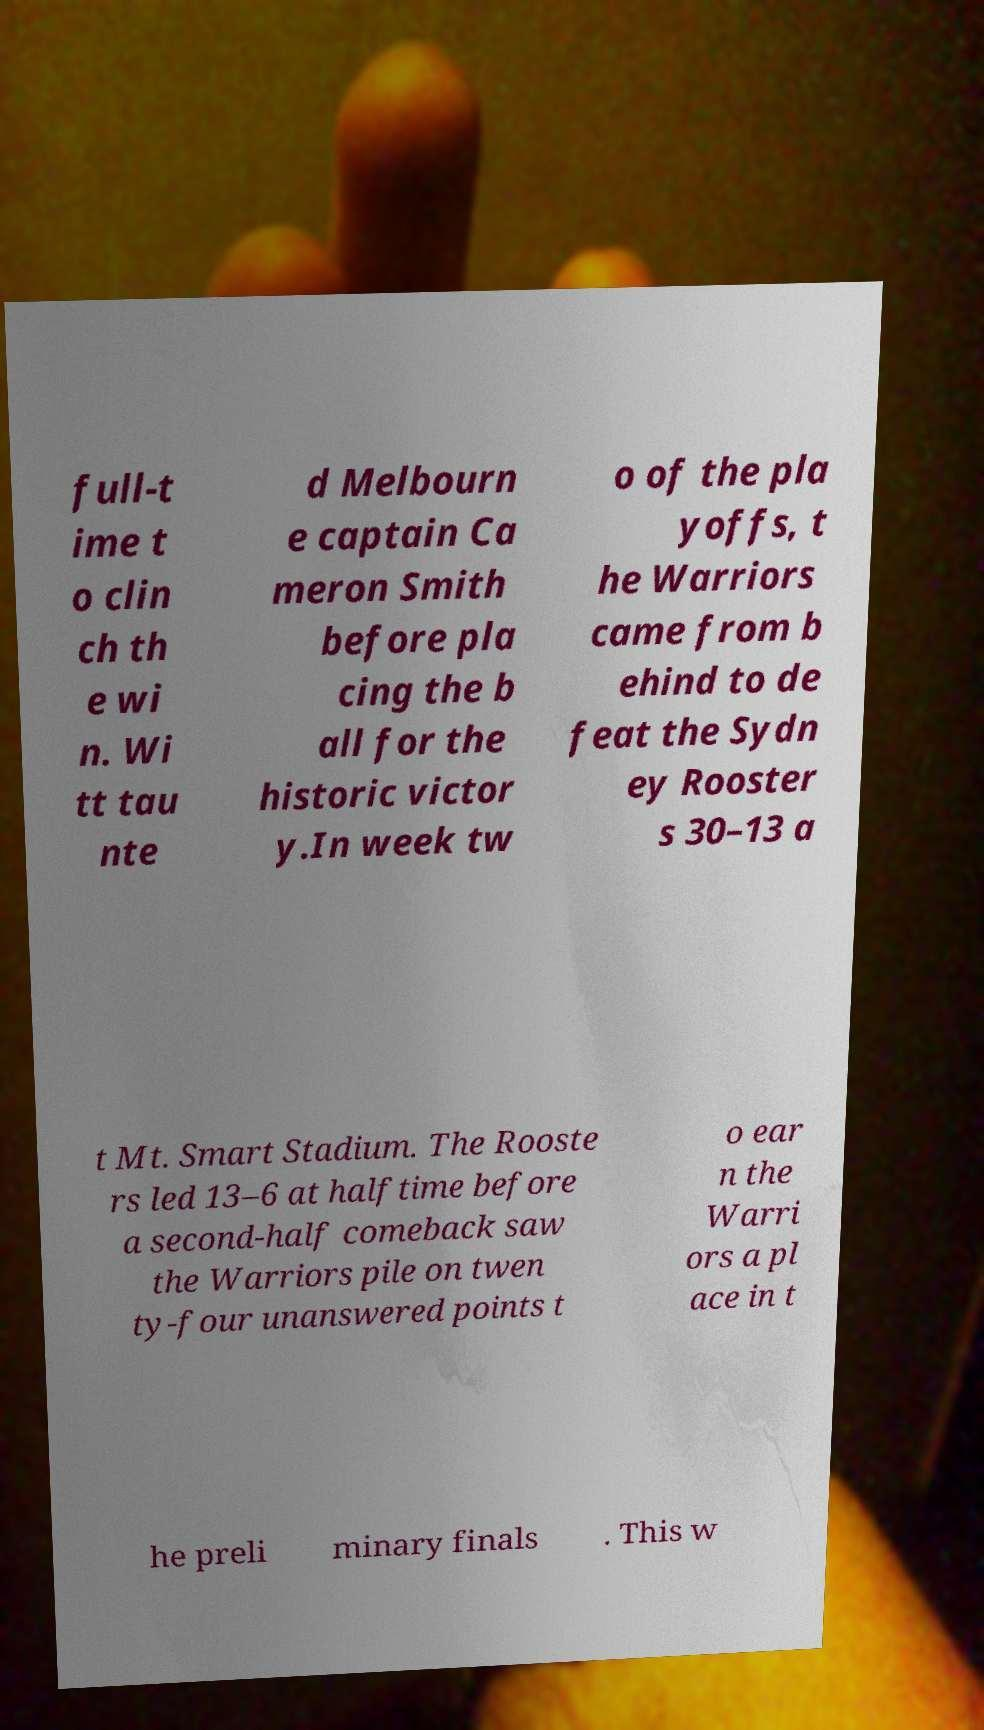Please read and relay the text visible in this image. What does it say? full-t ime t o clin ch th e wi n. Wi tt tau nte d Melbourn e captain Ca meron Smith before pla cing the b all for the historic victor y.In week tw o of the pla yoffs, t he Warriors came from b ehind to de feat the Sydn ey Rooster s 30–13 a t Mt. Smart Stadium. The Rooste rs led 13–6 at halftime before a second-half comeback saw the Warriors pile on twen ty-four unanswered points t o ear n the Warri ors a pl ace in t he preli minary finals . This w 